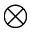Convert formula to latex. <formula><loc_0><loc_0><loc_500><loc_500>\otimes</formula> 